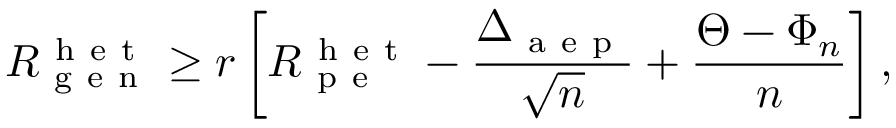<formula> <loc_0><loc_0><loc_500><loc_500>R _ { g e n } ^ { h e t } \geq r \left [ R _ { p e } ^ { h e t } - \frac { \Delta _ { a e p } } { \sqrt { n } } + \frac { \Theta - \Phi _ { n } } { n } \right ] ,</formula> 